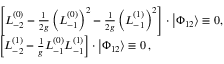<formula> <loc_0><loc_0><loc_500><loc_500>\begin{array} { r l } & { { \left [ L _ { - 2 } ^ { ( 0 ) } - \frac { 1 } { 2 g } \left ( L _ { - 1 } ^ { ( 0 ) } \right ) ^ { 2 } - \frac { 1 } { 2 g } \left ( L _ { - 1 } ^ { ( 1 ) } \right ) ^ { 2 } \right ] \cdot \left | \Phi _ { 1 2 } \right \rangle \equiv 0 , } } \\ & { { \left [ L _ { - 2 } ^ { ( 1 ) } - \frac { 1 } { g } L _ { - 1 } ^ { ( 0 ) } L _ { - 1 } ^ { ( 1 ) } \right ] \cdot \left | \Phi _ { 1 2 } \right \rangle \equiv 0 \, , } } \end{array}</formula> 